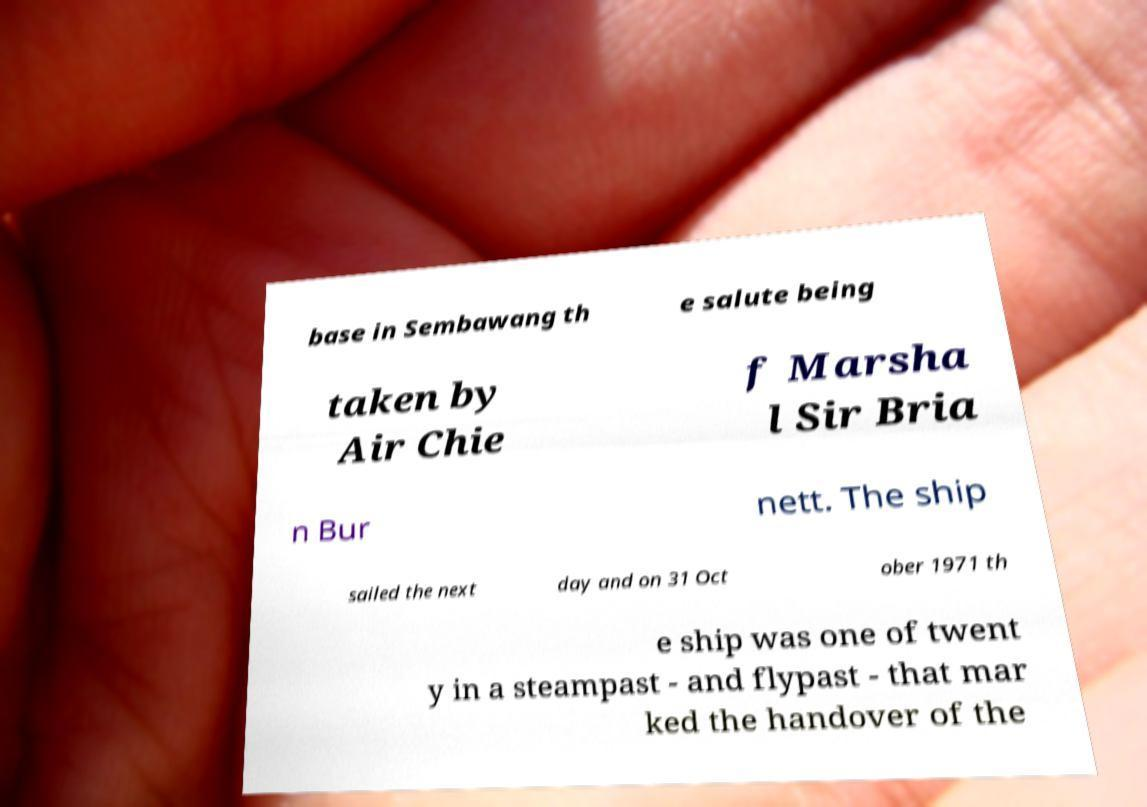What messages or text are displayed in this image? I need them in a readable, typed format. base in Sembawang th e salute being taken by Air Chie f Marsha l Sir Bria n Bur nett. The ship sailed the next day and on 31 Oct ober 1971 th e ship was one of twent y in a steampast - and flypast - that mar ked the handover of the 